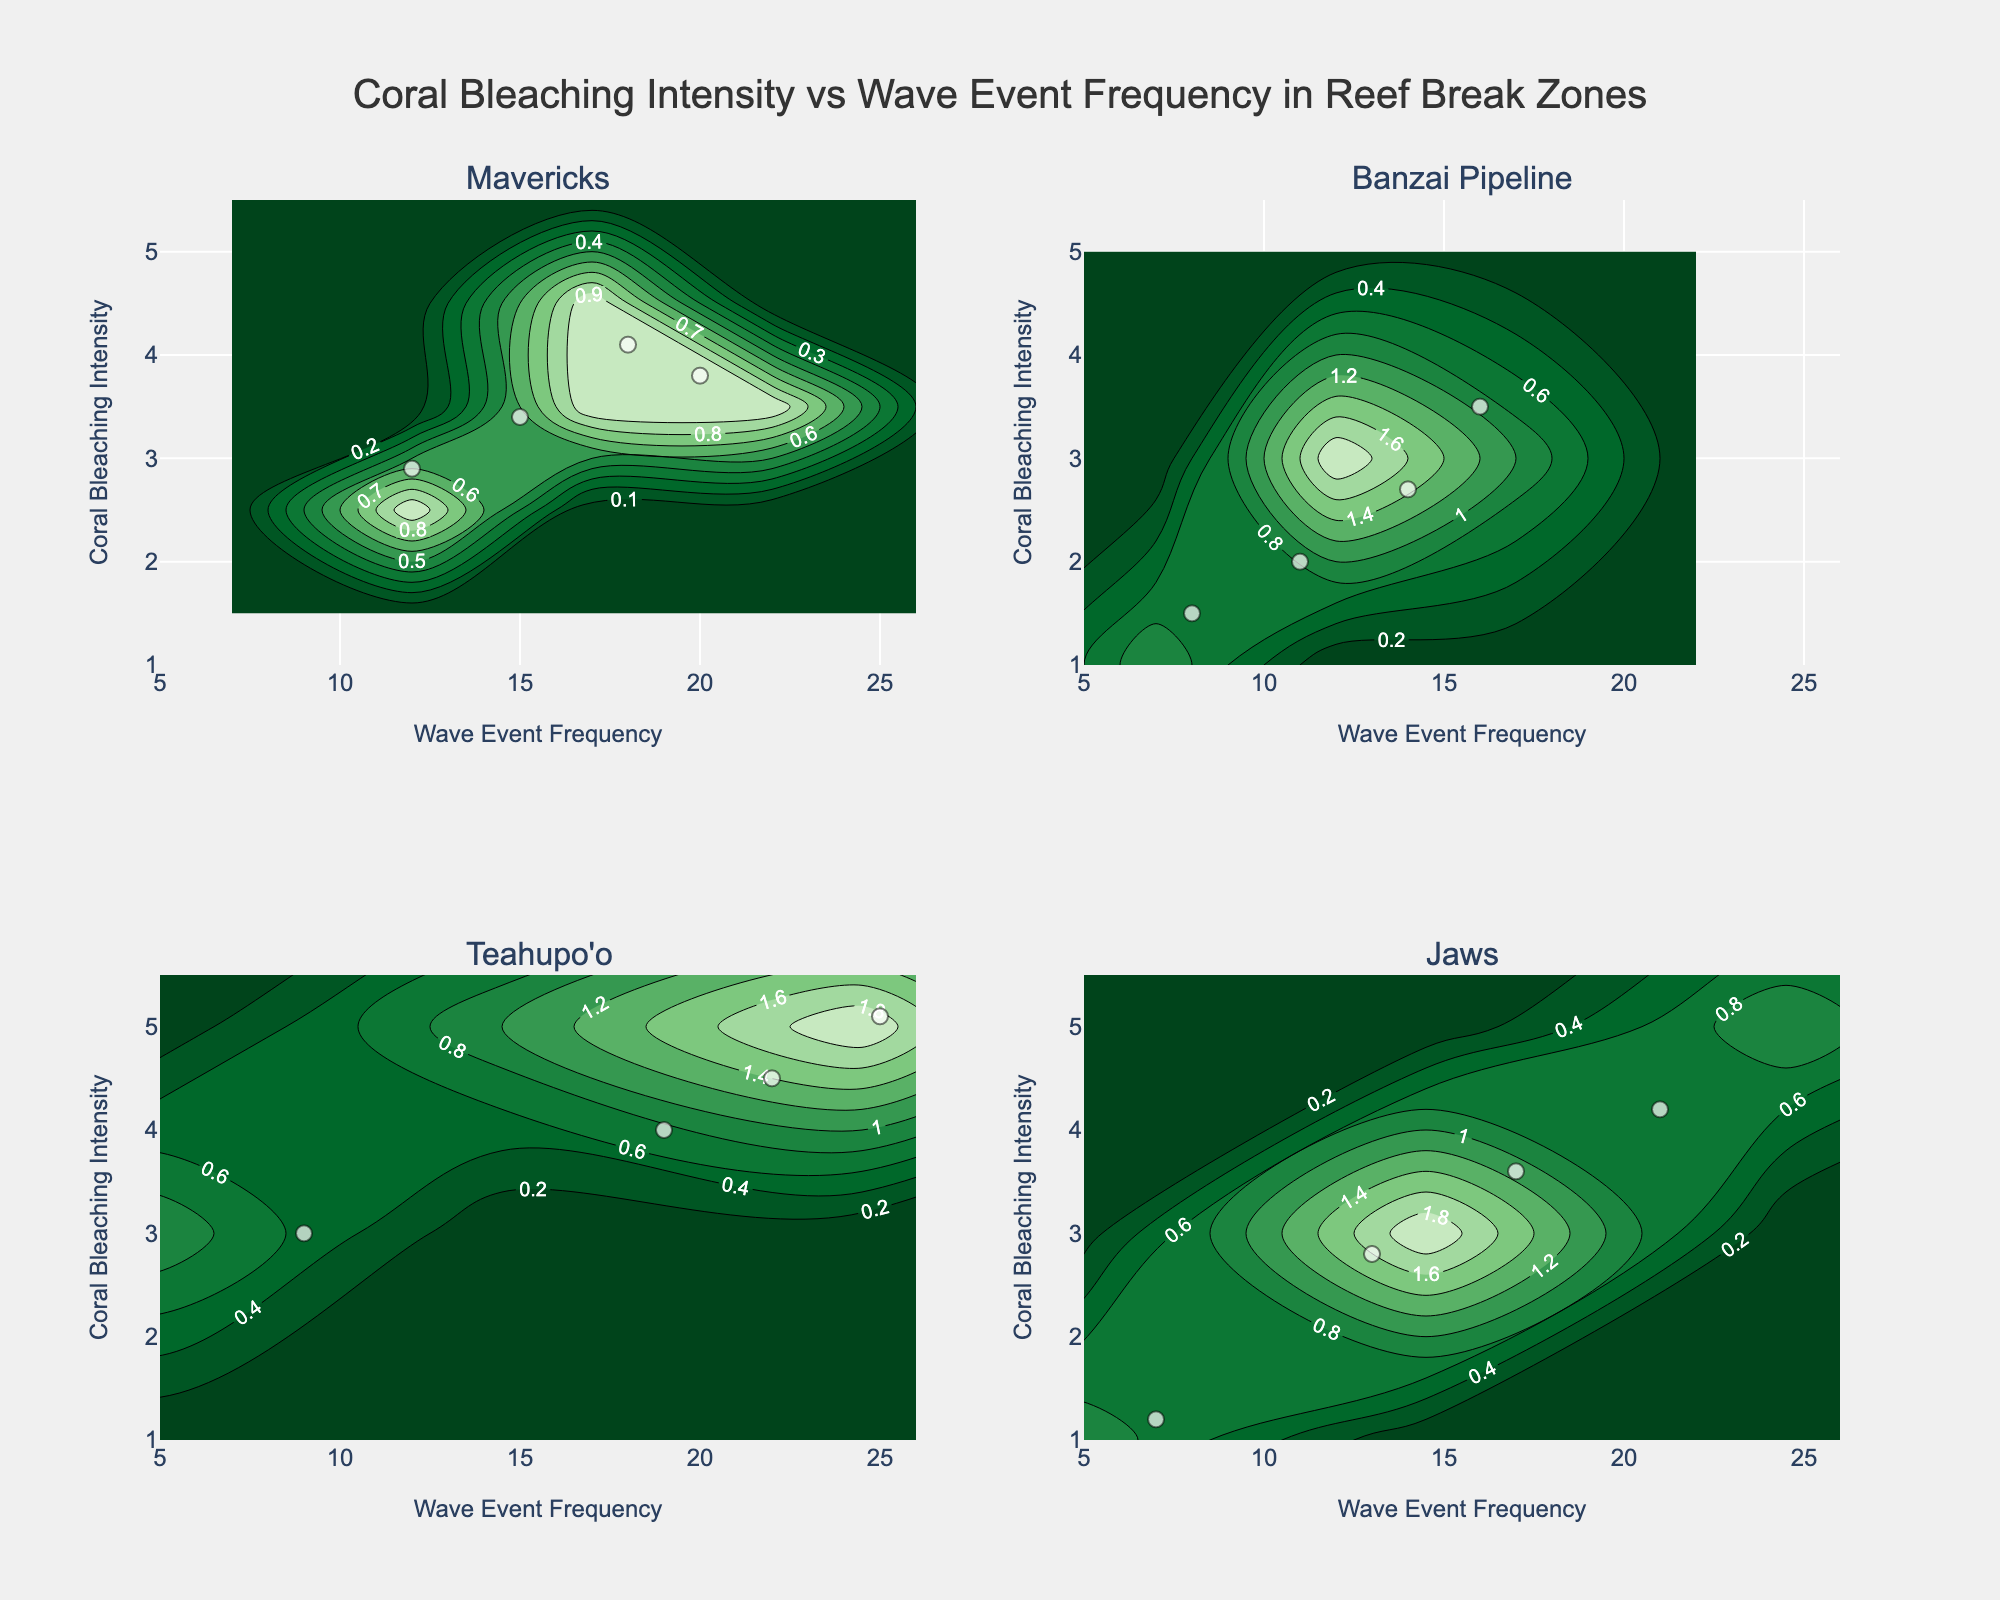What is the title of the figure? The title can be found at the top center of the figure, specifying the relationship being analyzed.
Answer: Coral Bleaching Intensity vs Wave Event Frequency in Reef Break Zones What is the range of the coral bleaching intensity axis? The range is shown along the y-axis, representing the minimum and maximum values.
Answer: 1 to 5.5 Which reef break zone appears to have the highest frequency of wave events? By looking at the x-axis across the subplots, compare the wave event frequencies shown.
Answer: Teahupo'o In the Mavericks subplot, how many data points have a wave event frequency greater than 15? Count the markers in the Mavericks subplot where the x-values are greater than 15.
Answer: 3 Which reef break zone shows the least variation in coral bleaching intensity? Assess the spread of data points along the y-axis in each subplot to determine which has the smallest range.
Answer: Jaws Compare the coral bleaching intensity between Banzai Pipeline and Teahupo'o. Which zone shows higher intensity overall? Compare the vertical positions of the data points (y-values) in the Banzai Pipeline and Teahupo'o subplots.
Answer: Teahupo'o What is the contour interval labeled on the color scale? The contours in the subplots are labeled at specific intervals indicating transition points on the color scale.
Answer: Every 0.75 units In the Jaws subplot, what is the wave event frequency when coral bleaching intensity is 4.2? Identify the data point in the Jaws subplot where the y-value is 4.2 and read off the corresponding x-value.
Answer: 21 What zone has the lowest overall wave event frequency? By examining the x-axes for each subplot, identify the zone with the lowest wave event frequency range.
Answer: Jaws In the Banzai Pipeline subplot, what is the most common wave event frequency observed? Look for the highest density of data points on the x-axis in the Banzai Pipeline subplot to determine the most frequent value.
Answer: 14 